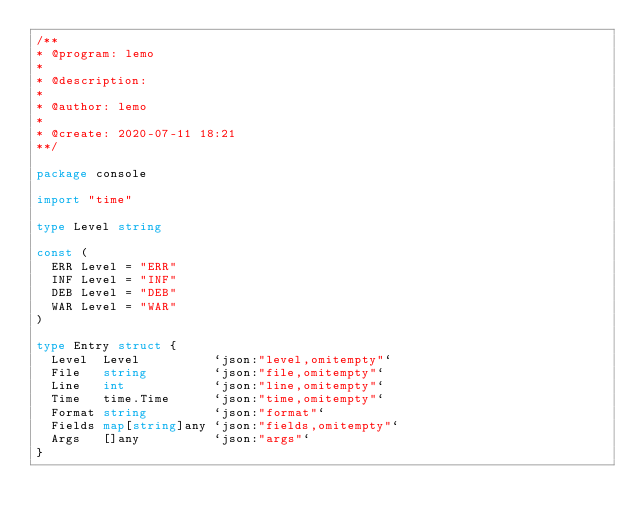<code> <loc_0><loc_0><loc_500><loc_500><_Go_>/**
* @program: lemo
*
* @description:
*
* @author: lemo
*
* @create: 2020-07-11 18:21
**/

package console

import "time"

type Level string

const (
	ERR Level = "ERR"
	INF Level = "INF"
	DEB Level = "DEB"
	WAR Level = "WAR"
)

type Entry struct {
	Level  Level          `json:"level,omitempty"`
	File   string         `json:"file,omitempty"`
	Line   int            `json:"line,omitempty"`
	Time   time.Time      `json:"time,omitempty"`
	Format string         `json:"format"`
	Fields map[string]any `json:"fields,omitempty"`
	Args   []any          `json:"args"`
}
</code> 